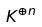Convert formula to latex. <formula><loc_0><loc_0><loc_500><loc_500>K ^ { \oplus n }</formula> 